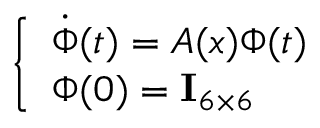Convert formula to latex. <formula><loc_0><loc_0><loc_500><loc_500>\left \{ \begin{array} { l } { \dot { \Phi } ( t ) = A ( x ) \Phi ( t ) } \\ { \Phi ( 0 ) = I _ { 6 \times 6 } } \end{array}</formula> 